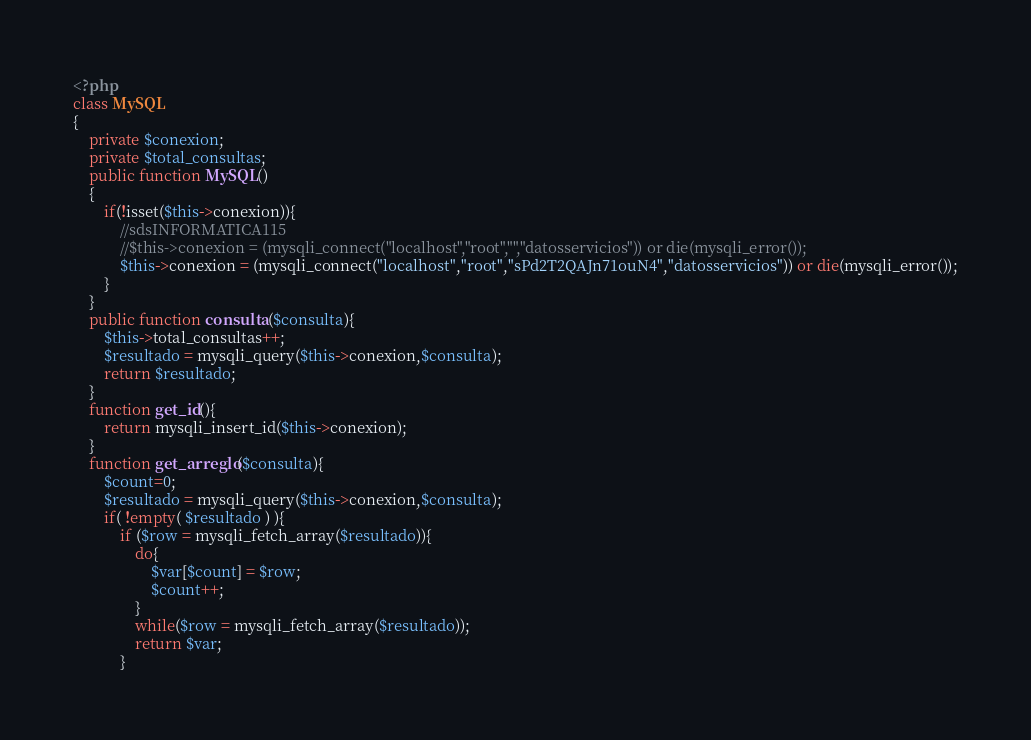<code> <loc_0><loc_0><loc_500><loc_500><_PHP_><?php
class MySQL
{
	private $conexion;
	private $total_consultas;
	public function MySQL()
	{
		if(!isset($this->conexion)){
			//sdsINFORMATICA115
			//$this->conexion = (mysqli_connect("localhost","root","","datosservicios")) or die(mysqli_error());
            $this->conexion = (mysqli_connect("localhost","root","sPd2T2QAJn71ouN4","datosservicios")) or die(mysqli_error());
		}
	}
	public function consulta($consulta){
		$this->total_consultas++;
		$resultado = mysqli_query($this->conexion,$consulta);
		return $resultado;
	}
	function get_id(){
		return mysqli_insert_id($this->conexion);
	}
	function get_arreglo($consulta){
		$count=0;
		$resultado = mysqli_query($this->conexion,$consulta);
		if( !empty( $resultado ) ){
			if ($row = mysqli_fetch_array($resultado)){
				do{
					$var[$count] = $row;
					$count++;
				}
				while($row = mysqli_fetch_array($resultado));
				return $var;
			}</code> 